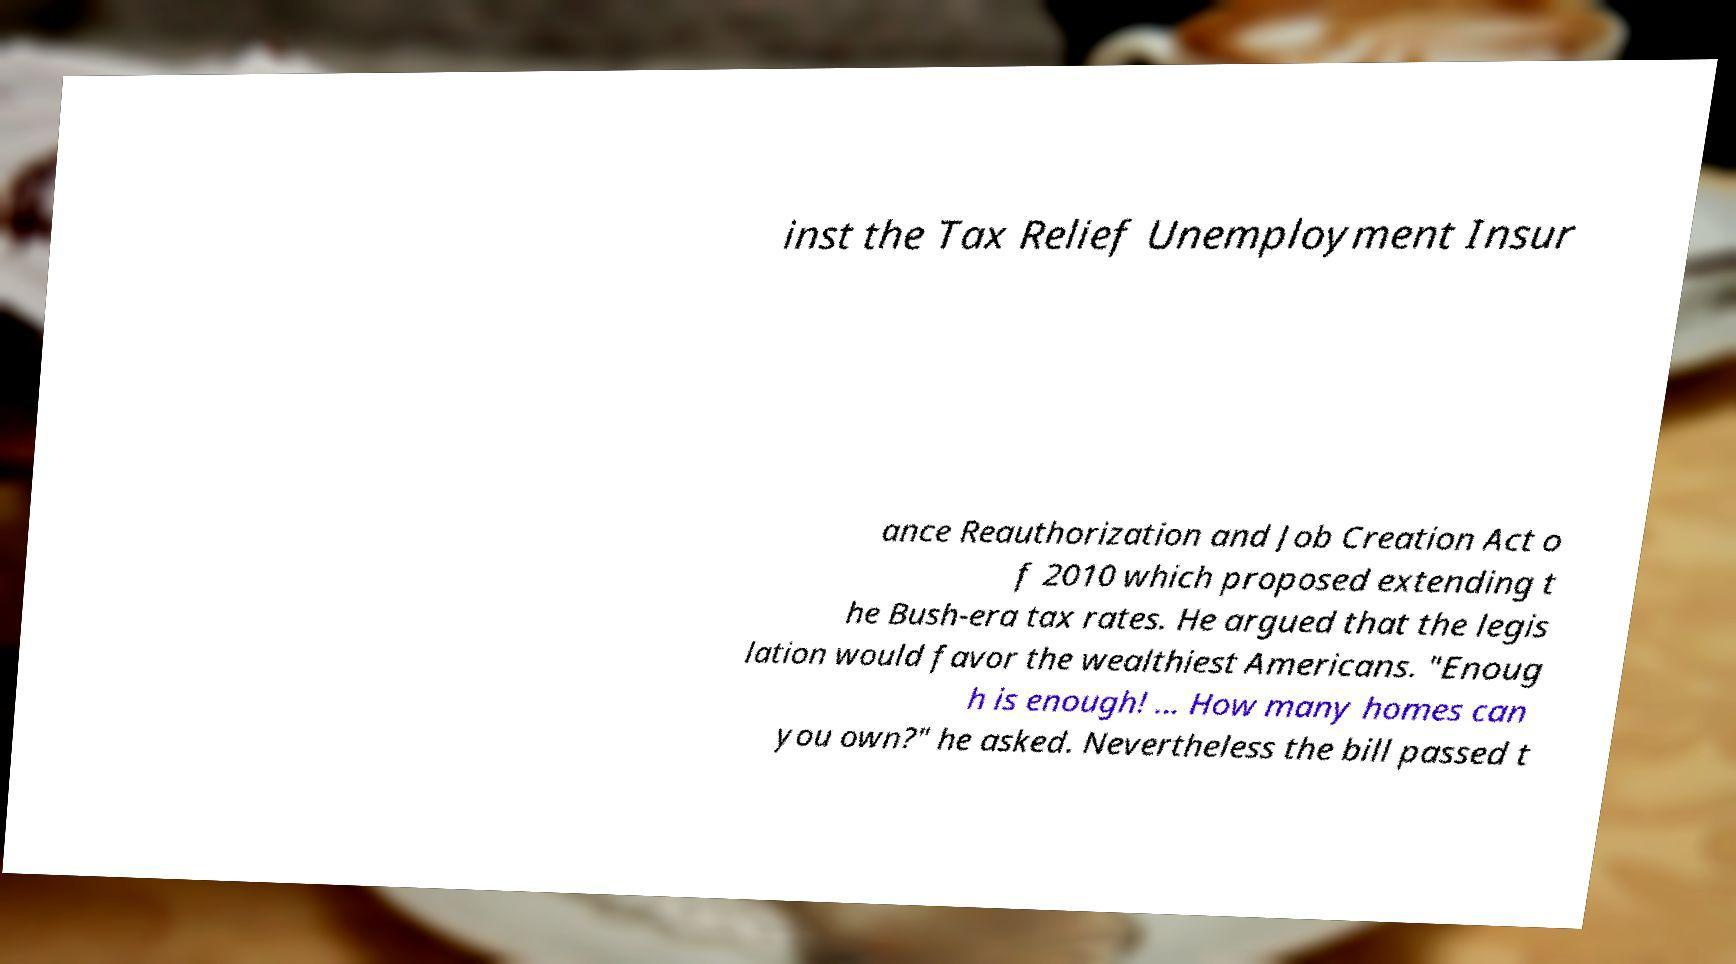Can you accurately transcribe the text from the provided image for me? inst the Tax Relief Unemployment Insur ance Reauthorization and Job Creation Act o f 2010 which proposed extending t he Bush-era tax rates. He argued that the legis lation would favor the wealthiest Americans. "Enoug h is enough! ... How many homes can you own?" he asked. Nevertheless the bill passed t 